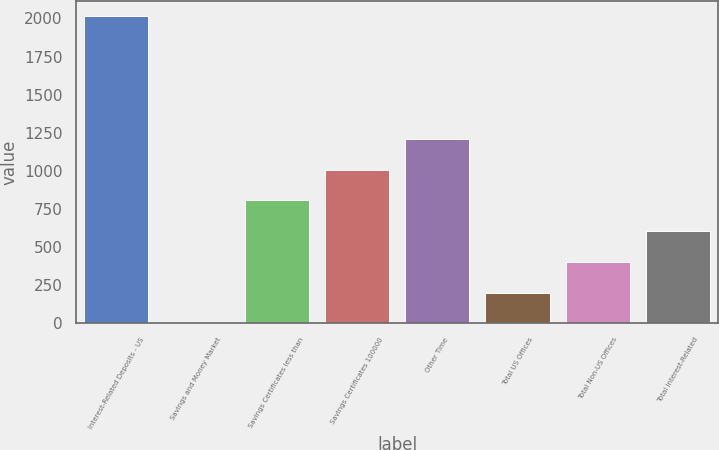Convert chart to OTSL. <chart><loc_0><loc_0><loc_500><loc_500><bar_chart><fcel>Interest-Related Deposits - US<fcel>Savings and Money Market<fcel>Savings Certificates less than<fcel>Savings Certificates 100000<fcel>Other Time<fcel>Total US Offices<fcel>Total Non-US Offices<fcel>Total Interest-Related<nl><fcel>2016<fcel>0.08<fcel>806.44<fcel>1008.03<fcel>1209.62<fcel>201.67<fcel>403.26<fcel>604.85<nl></chart> 